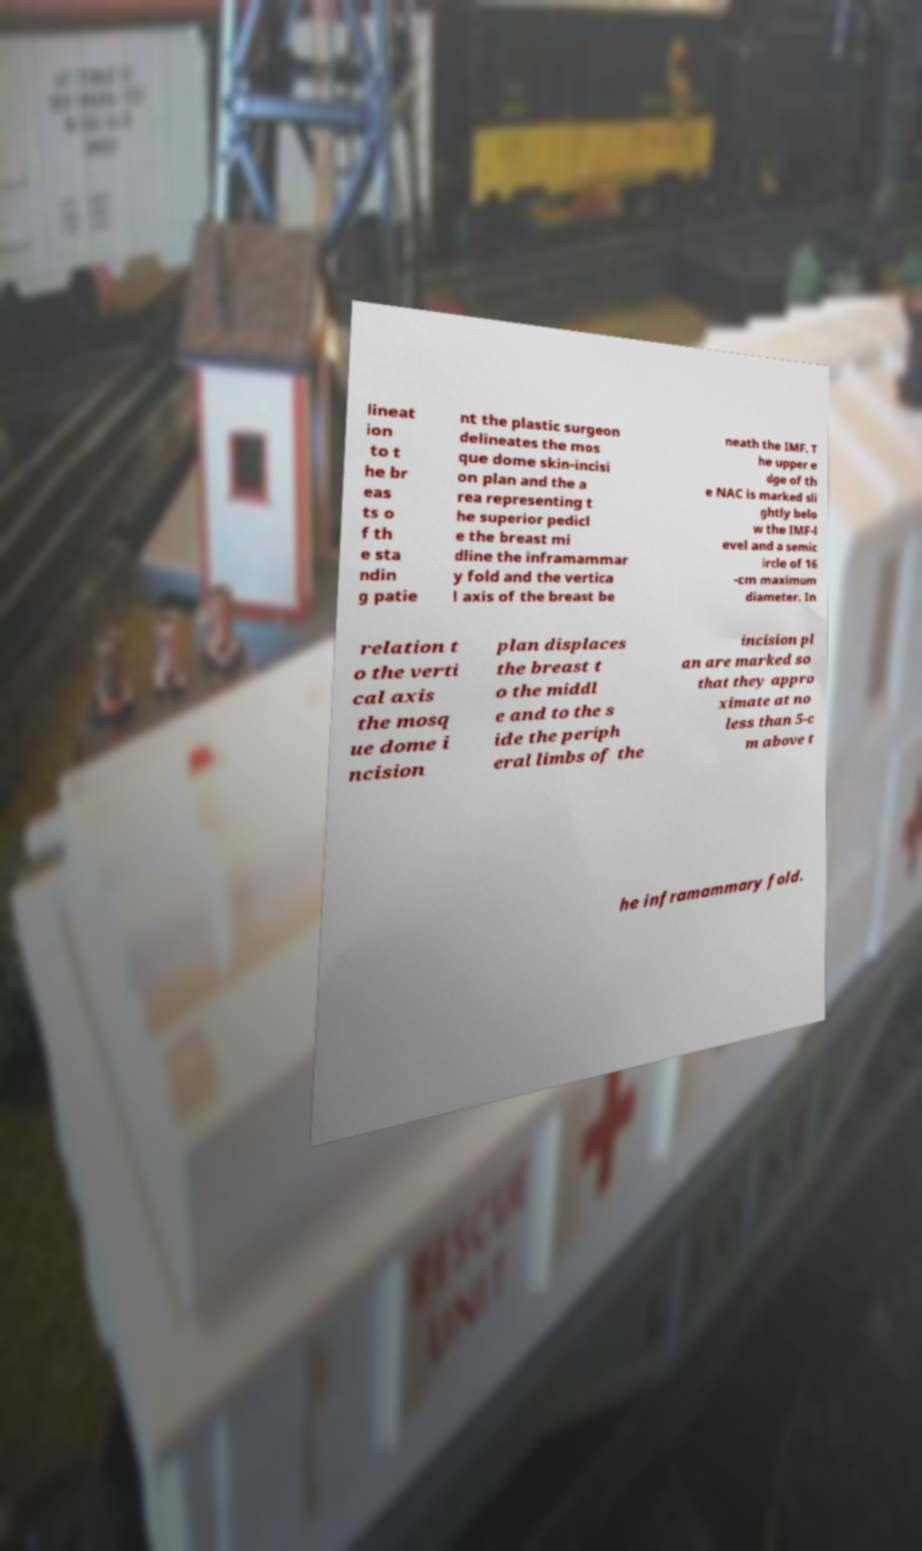Could you assist in decoding the text presented in this image and type it out clearly? lineat ion to t he br eas ts o f th e sta ndin g patie nt the plastic surgeon delineates the mos que dome skin-incisi on plan and the a rea representing t he superior pedicl e the breast mi dline the inframammar y fold and the vertica l axis of the breast be neath the IMF. T he upper e dge of th e NAC is marked sli ghtly belo w the IMF-l evel and a semic ircle of 16 -cm maximum diameter. In relation t o the verti cal axis the mosq ue dome i ncision plan displaces the breast t o the middl e and to the s ide the periph eral limbs of the incision pl an are marked so that they appro ximate at no less than 5-c m above t he inframammary fold. 